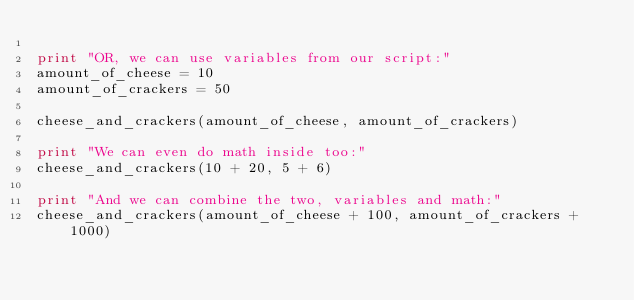<code> <loc_0><loc_0><loc_500><loc_500><_Python_>
print "OR, we can use variables from our script:"
amount_of_cheese = 10
amount_of_crackers = 50

cheese_and_crackers(amount_of_cheese, amount_of_crackers)

print "We can even do math inside too:"
cheese_and_crackers(10 + 20, 5 + 6)

print "And we can combine the two, variables and math:"
cheese_and_crackers(amount_of_cheese + 100, amount_of_crackers + 1000)	</code> 